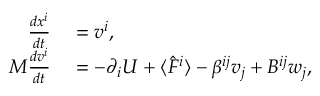Convert formula to latex. <formula><loc_0><loc_0><loc_500><loc_500>\begin{array} { r l } { \frac { d x ^ { i } } { d t } } & = v ^ { i } , } \\ { M \frac { d v ^ { i } } { d t } } & = - \partial _ { i } U + \langle \hat { F } ^ { i } \rangle - \beta ^ { i j } v _ { j } + B ^ { i j } w _ { j } , } \end{array}</formula> 